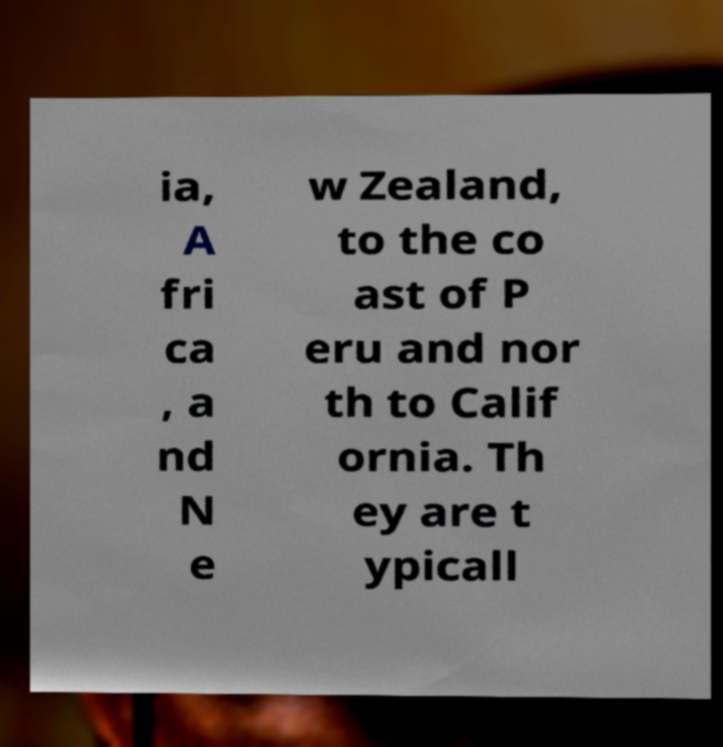For documentation purposes, I need the text within this image transcribed. Could you provide that? ia, A fri ca , a nd N e w Zealand, to the co ast of P eru and nor th to Calif ornia. Th ey are t ypicall 